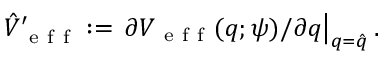<formula> <loc_0><loc_0><loc_500><loc_500>\hat { V } _ { e f f } ^ { \prime } \colon = \partial V _ { e f f } ( q ; \psi ) / \partial q \right | _ { q = \hat { q } } .</formula> 